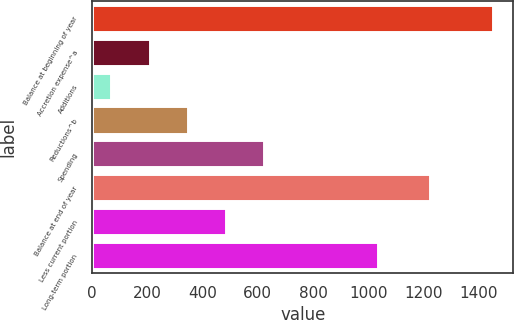Convert chart. <chart><loc_0><loc_0><loc_500><loc_500><bar_chart><fcel>Balance at beginning of year<fcel>Accretion expense^a<fcel>Additions<fcel>Reductions^b<fcel>Spending<fcel>Balance at end of year<fcel>Less current portion<fcel>Long-term portion<nl><fcel>1453<fcel>208.3<fcel>70<fcel>346.6<fcel>623.2<fcel>1222<fcel>484.9<fcel>1036<nl></chart> 